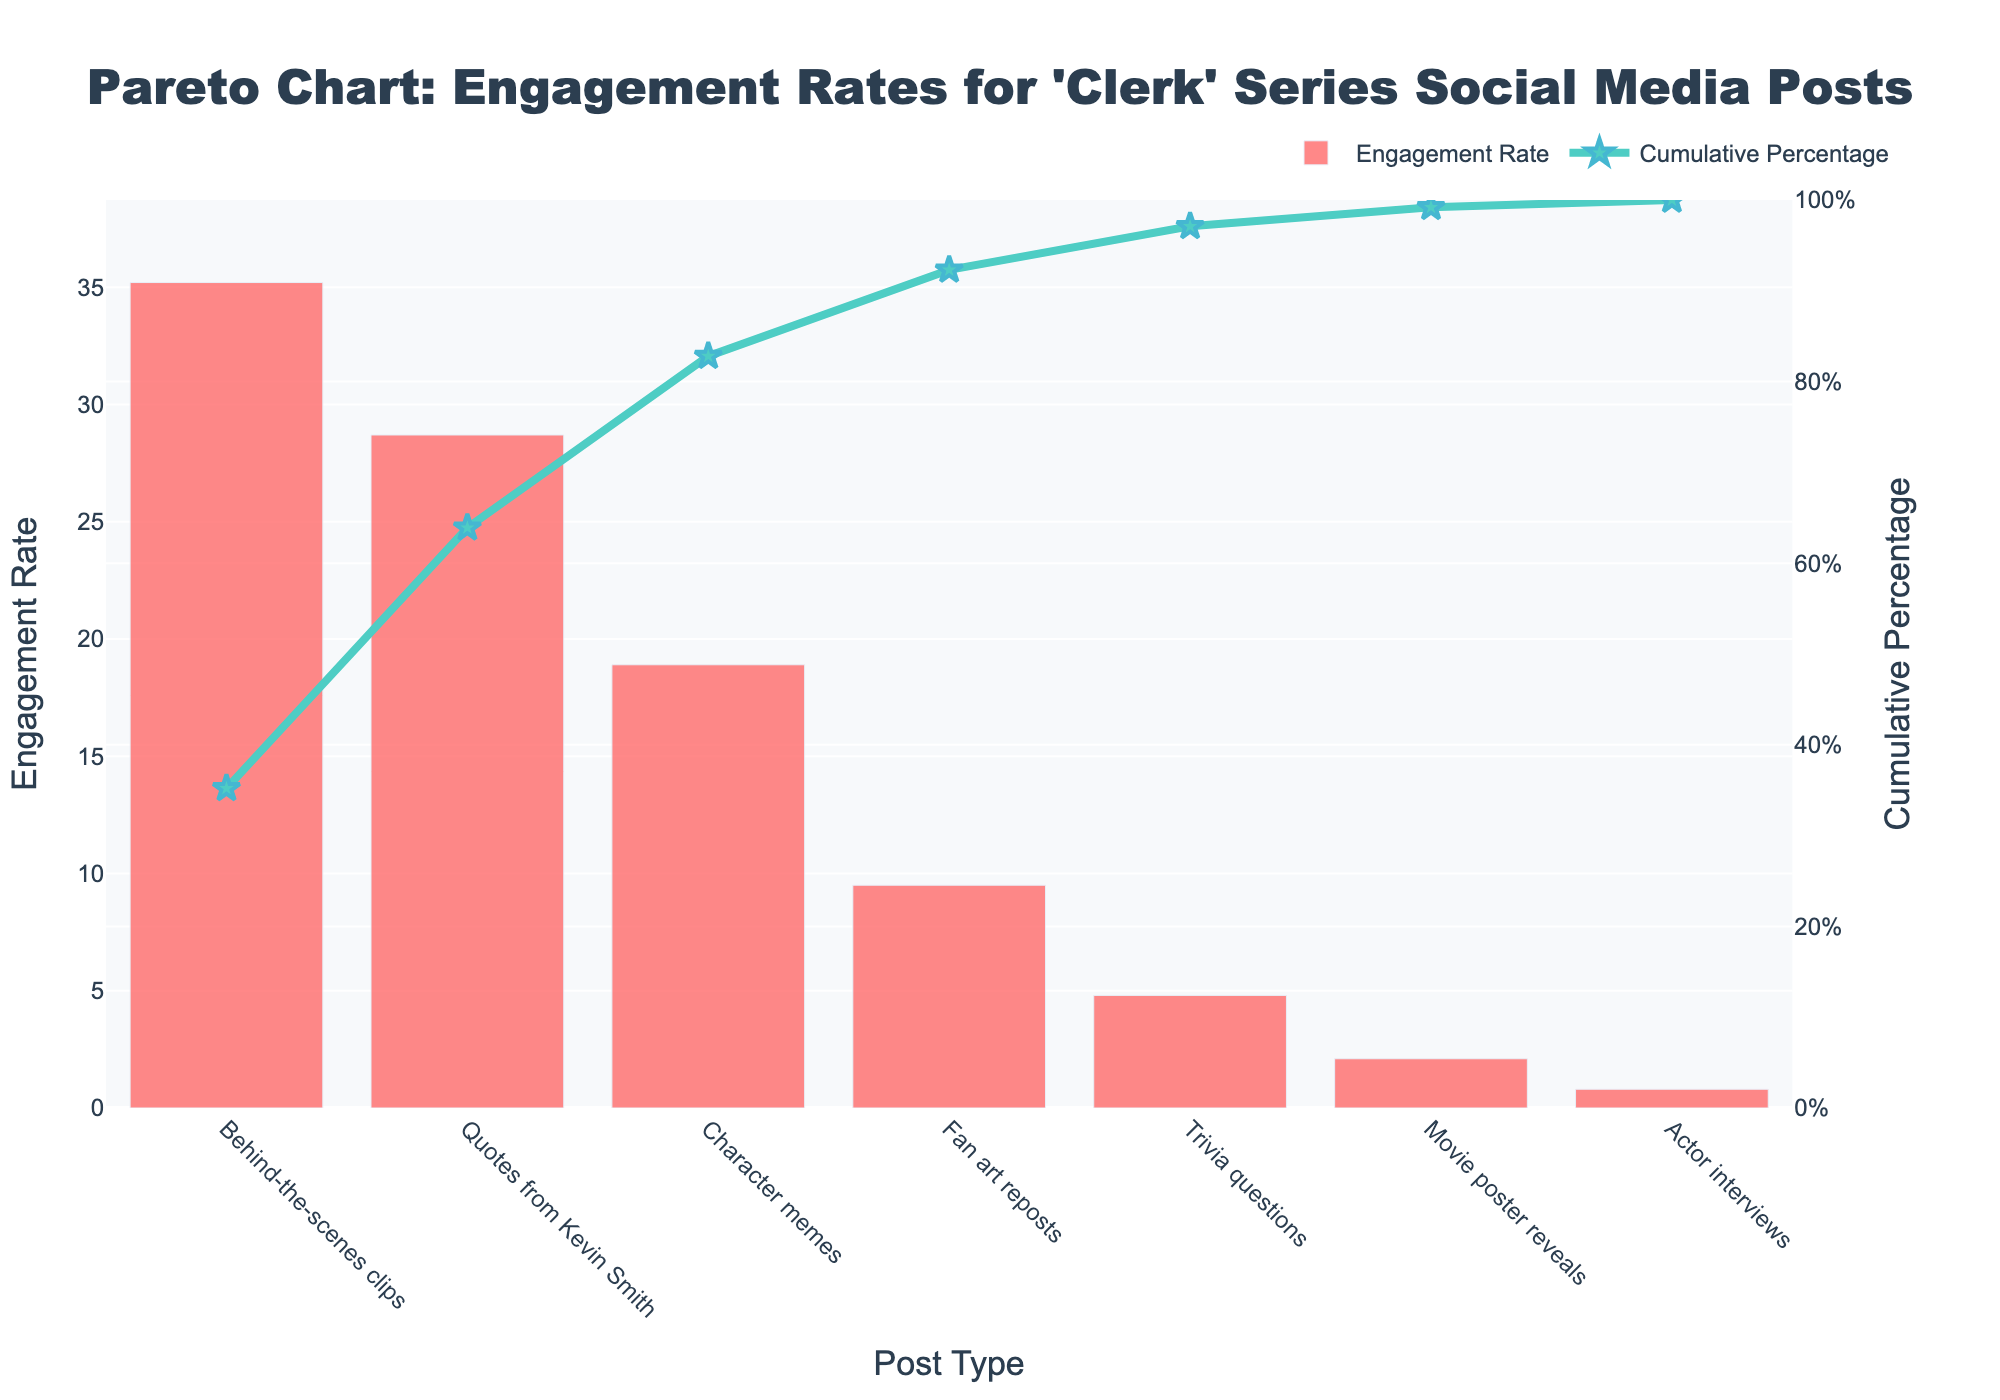What is the title of the chart? The title of the chart can be found at the top center. It reads "Pareto Chart: Engagement Rates for 'Clerk' Series Social Media Posts".
Answer: Pareto Chart: Engagement Rates for 'Clerk' Series Social Media Posts Which post type has the highest engagement rate? The highest bar in the bar chart represents the post type with the highest engagement rate. It's labeled "Behind-the-scenes clips".
Answer: Behind-the-scenes clips How many percentage points make up the cumulative percentage for the first three post types? To find this, look at the cumulative percentage markers on the line chart for "Behind-the-scenes clips", "Quotes from Kevin Smith", and "Character memes". The cumulative percentages are 35.2%, 63.9%, and 82.8%. Summing these up gives us 82.8%.
Answer: 82.8% Which post types make up over 80% of the cumulative engagement rate? The red line chart indicates the cumulative percentage; the point at which it crosses 80% includes the top three post types: "Behind-the-scenes clips", "Quotes from Kevin Smith", and "Character memes".
Answer: Behind-the-scenes clips, Quotes from Kevin Smith, Character memes What is the engagement rate for fan art reposts and how does it compare to actor interviews? The engagement rate for "Fan art reposts" is displayed as a bar with a height of 9.5%. The bar for "Actor interviews" has a height of 0.8%. To compare: 9.5% is significantly higher than 0.8%.
Answer: Fan art reposts: 9.5%, higher than Actor interviews: 0.8% At which post type does the cumulative percentage reach over 90%? Observing the cumulative percentage line, it crosses 90% after the "Trivia questions" post type.
Answer: Trivia questions How much higher is the engagement rate for behind-the-scenes clips compared to movie poster reveals? The engagement rate for "Behind-the-scenes clips" is 35.2%, while for "Movie poster reveals" it is 2.1%. The difference is 35.2% - 2.1% = 33.1%.
Answer: 33.1% What's the combined engagement rate for trivia questions and character memes? The engagement rates for "Trivia questions" and "Character memes" are 4.8% and 18.9% respectively. Summing these, 4.8% + 18.9% = 23.7%.
Answer: 23.7% What percentage of the overall engagement rate does the top post type represent? The engagement rate for "Behind-the-scenes clips" is 35.2%. Since it is the top post type, this percentage directly represents its contribution to the overall engagement rate.
Answer: 35.2% How does the engagement rate for quotes from Kevin Smith compare to character memes? The engagement rate for "Quotes from Kevin Smith" is 28.7%, and for "Character memes" it is 18.9%. 28.7% is higher than 18.9%.
Answer: Quotes from Kevin Smith: 28.7%, Character memes: 18.9%, Quotes are higher 